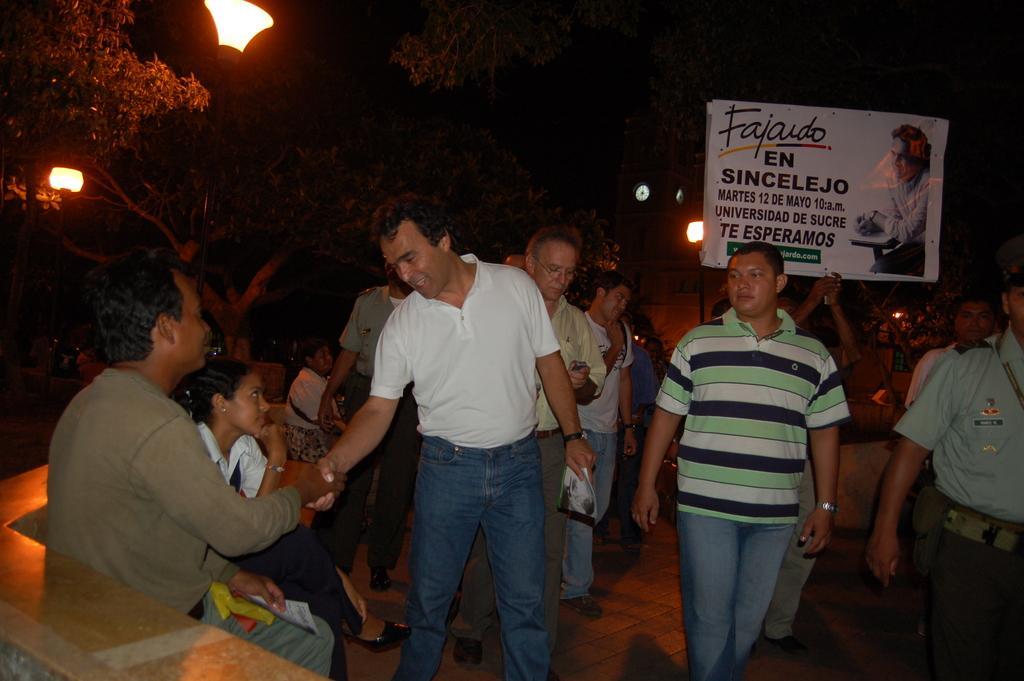In one or two sentences, can you explain what this image depicts? In the picture I can see few people. I can see two men shaking the hands. There are trees on the left side and I can see the lights. There is a banner on the top right side of the picture. 